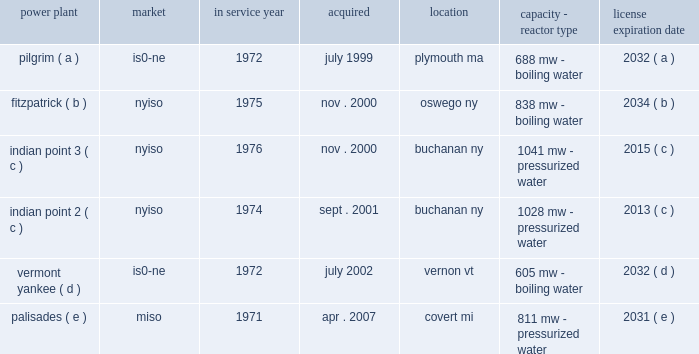Part i item 1 entergy corporation , utility operating companies , and system energy including the continued effectiveness of the clean energy standards/zero emissions credit program ( ces/zec ) , the establishment of certain long-term agreements on acceptable terms with the energy research and development authority of the state of new york in connection with the ces/zec program , and nypsc approval of the transaction on acceptable terms , entergy refueled the fitzpatrick plant in january and february 2017 .
In october 2015 , entergy determined that it would close the pilgrim plant .
The decision came after management 2019s extensive analysis of the economics and operating life of the plant following the nrc 2019s decision in september 2015 to place the plant in its 201cmultiple/repetitive degraded cornerstone column 201d ( column 4 ) of its reactor oversight process action matrix .
The pilgrim plant is expected to cease operations on may 31 , 2019 , after refueling in the spring of 2017 and operating through the end of that fuel cycle .
In december 2015 , entergy wholesale commodities closed on the sale of its 583 mw rhode island state energy center ( risec ) , in johnston , rhode island .
The base sales price , excluding adjustments , was approximately $ 490 million .
Entergy wholesale commodities purchased risec for $ 346 million in december 2011 .
In december 2016 , entergy announced that it reached an agreement with consumers energy to terminate the ppa for the palisades plant on may 31 , 2018 .
Pursuant to the ppa termination agreement , consumers energy will pay entergy $ 172 million for the early termination of the ppa .
The ppa termination agreement is subject to regulatory approvals .
Separately , and assuming regulatory approvals are obtained for the ppa termination agreement , entergy intends to shut down the palisades nuclear power plant permanently on october 1 , 2018 , after refueling in the spring of 2017 and operating through the end of that fuel cycle .
Entergy expects to enter into a new ppa with consumers energy under which the plant would continue to operate through october 1 , 2018 .
In january 2017 , entergy announced that it reached a settlement with new york state to shut down indian point 2 by april 30 , 2020 and indian point 3 by april 30 , 2021 , and resolve all new york state-initiated legal challenges to indian point 2019s operating license renewal .
As part of the settlement , new york state has agreed to issue indian point 2019s water quality certification and coastal zone management act consistency certification and to withdraw its objection to license renewal before the nrc .
New york state also has agreed to issue a water discharge permit , which is required regardless of whether the plant is seeking a renewed nrc license .
The shutdowns are conditioned , among other things , upon such actions being taken by new york state .
Even without opposition , the nrc license renewal process is expected to continue at least into 2018 .
With the settlement concerning indian point , entergy now has announced plans for the disposition of all of the entergy wholesale commodities nuclear power plants , including the sales of vermont yankee and fitzpatrick , and the earlier than previously expected shutdowns of pilgrim , palisades , indian point 2 , and indian point 3 .
See 201centergy wholesale commodities exit from the merchant power business 201d for further discussion .
Property nuclear generating stations entergy wholesale commodities includes the ownership of the following nuclear power plants : power plant market service year acquired location capacity - reactor type license expiration .

How many years did it take to close the pilgrim plant after after its last refueling? 
Computations: (2019 - 2017)
Answer: 2.0. 